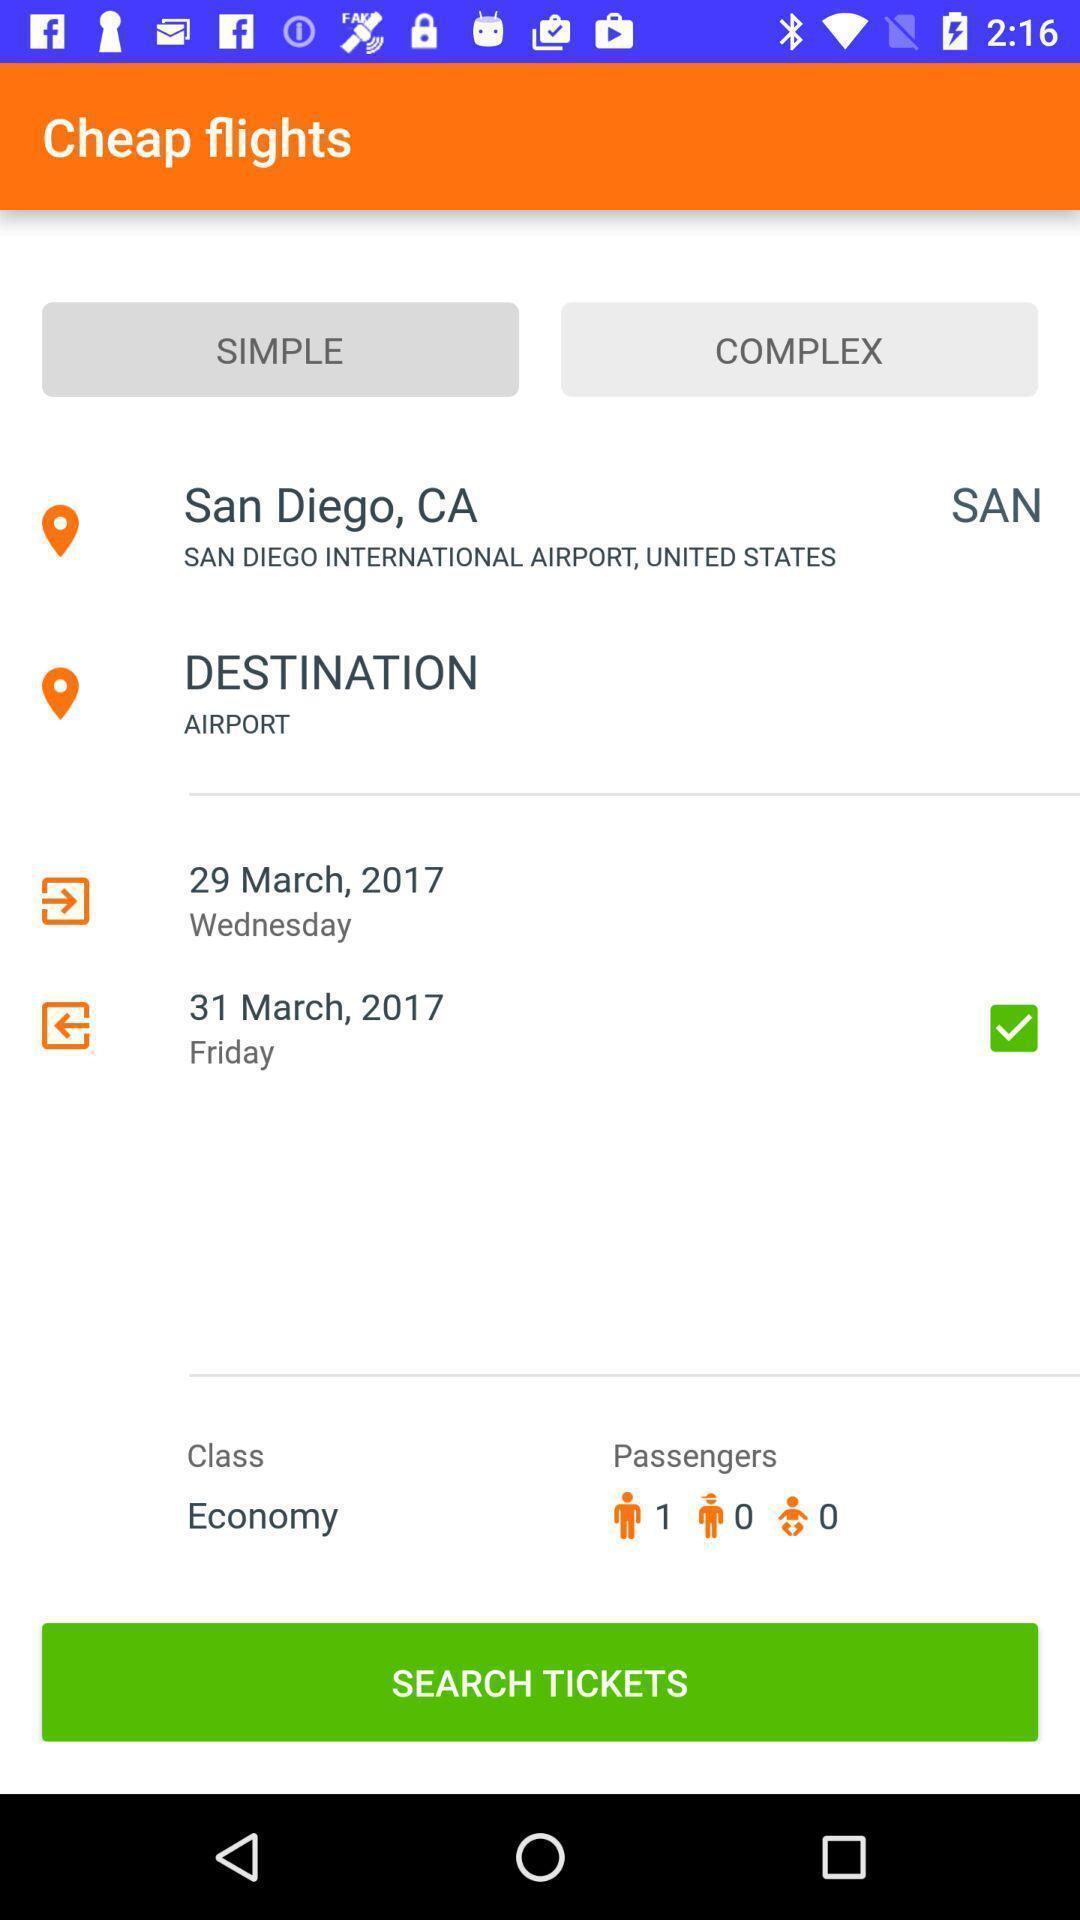What details can you identify in this image? Page to search flight tickets. 